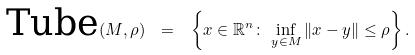<formula> <loc_0><loc_0><loc_500><loc_500>\text {Tube} ( M , \rho ) \ = \ \left \{ x \in \mathbb { R } ^ { n } \colon \, \inf _ { y \in M } \| x - y \| \leq \rho \right \} .</formula> 